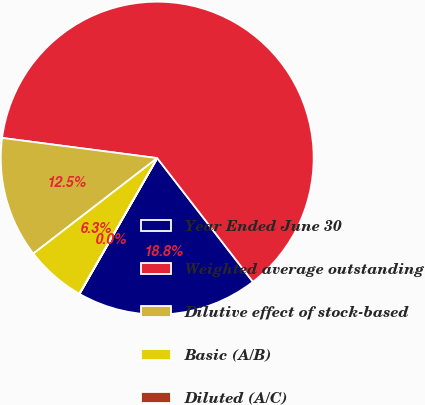Convert chart. <chart><loc_0><loc_0><loc_500><loc_500><pie_chart><fcel>Year Ended June 30<fcel>Weighted average outstanding<fcel>Dilutive effect of stock-based<fcel>Basic (A/B)<fcel>Diluted (A/C)<nl><fcel>18.75%<fcel>62.46%<fcel>12.51%<fcel>6.26%<fcel>0.02%<nl></chart> 